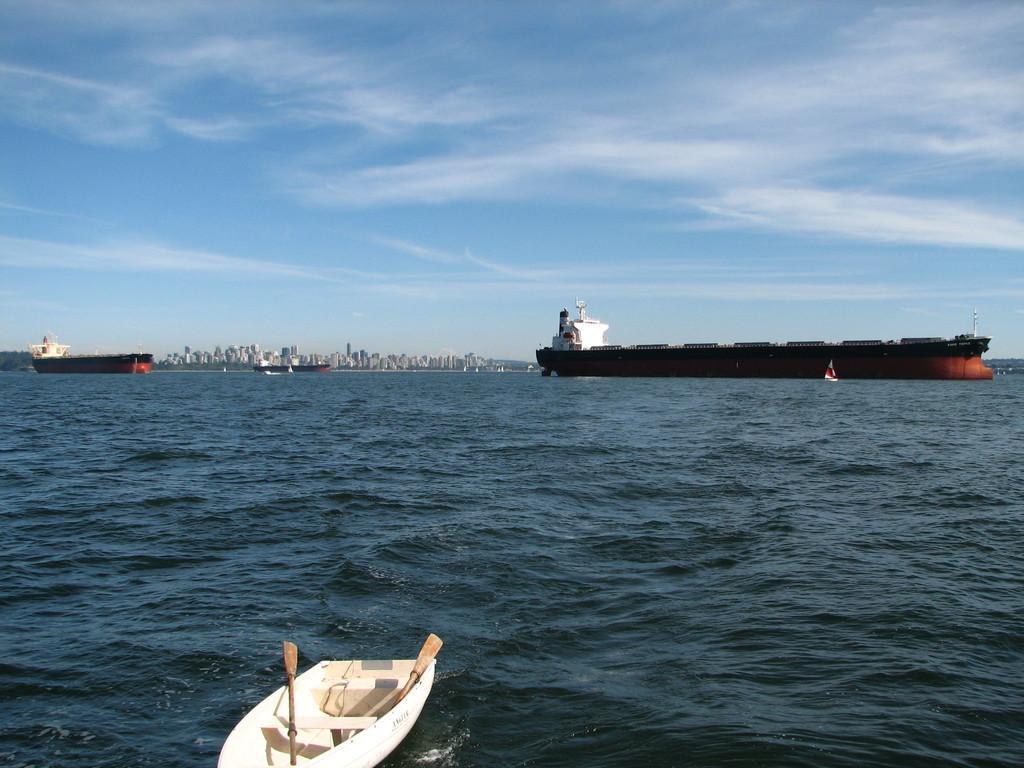How would you summarize this image in a sentence or two? In the image we can see there is a boat in the water and this is a water. We can even see there are many buildings and a cloudy sky. 